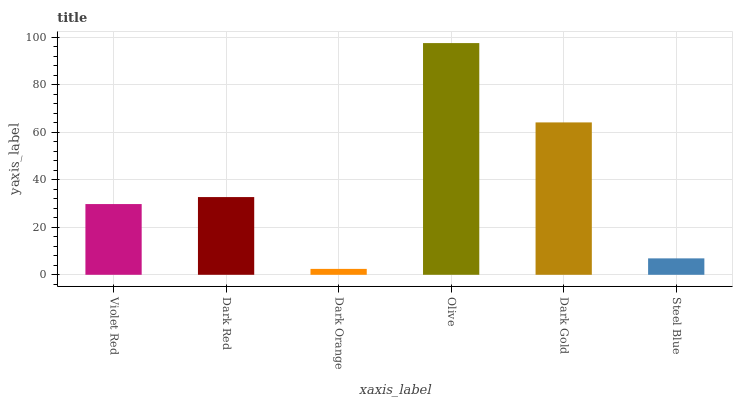Is Dark Red the minimum?
Answer yes or no. No. Is Dark Red the maximum?
Answer yes or no. No. Is Dark Red greater than Violet Red?
Answer yes or no. Yes. Is Violet Red less than Dark Red?
Answer yes or no. Yes. Is Violet Red greater than Dark Red?
Answer yes or no. No. Is Dark Red less than Violet Red?
Answer yes or no. No. Is Dark Red the high median?
Answer yes or no. Yes. Is Violet Red the low median?
Answer yes or no. Yes. Is Dark Orange the high median?
Answer yes or no. No. Is Olive the low median?
Answer yes or no. No. 